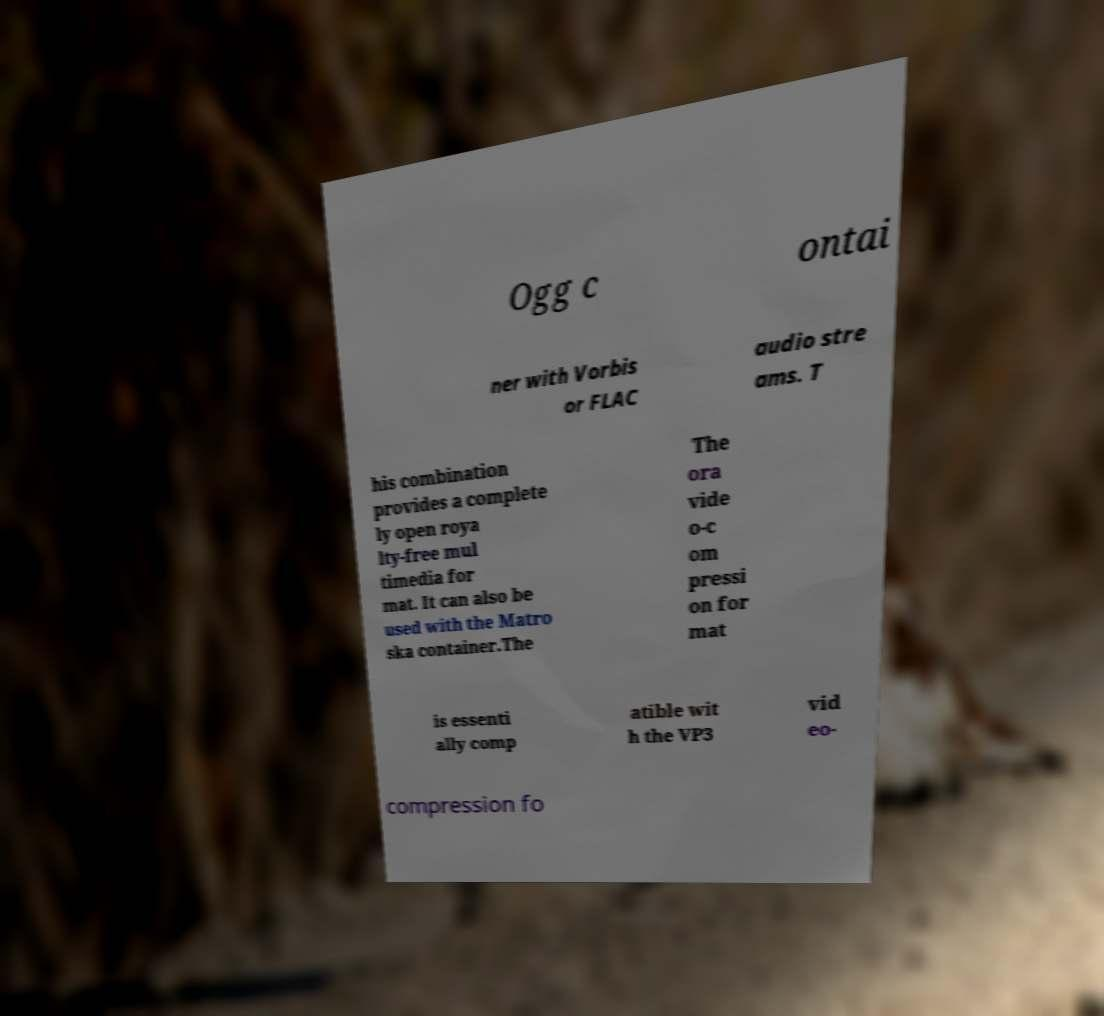What messages or text are displayed in this image? I need them in a readable, typed format. Ogg c ontai ner with Vorbis or FLAC audio stre ams. T his combination provides a complete ly open roya lty-free mul timedia for mat. It can also be used with the Matro ska container.The The ora vide o-c om pressi on for mat is essenti ally comp atible wit h the VP3 vid eo- compression fo 